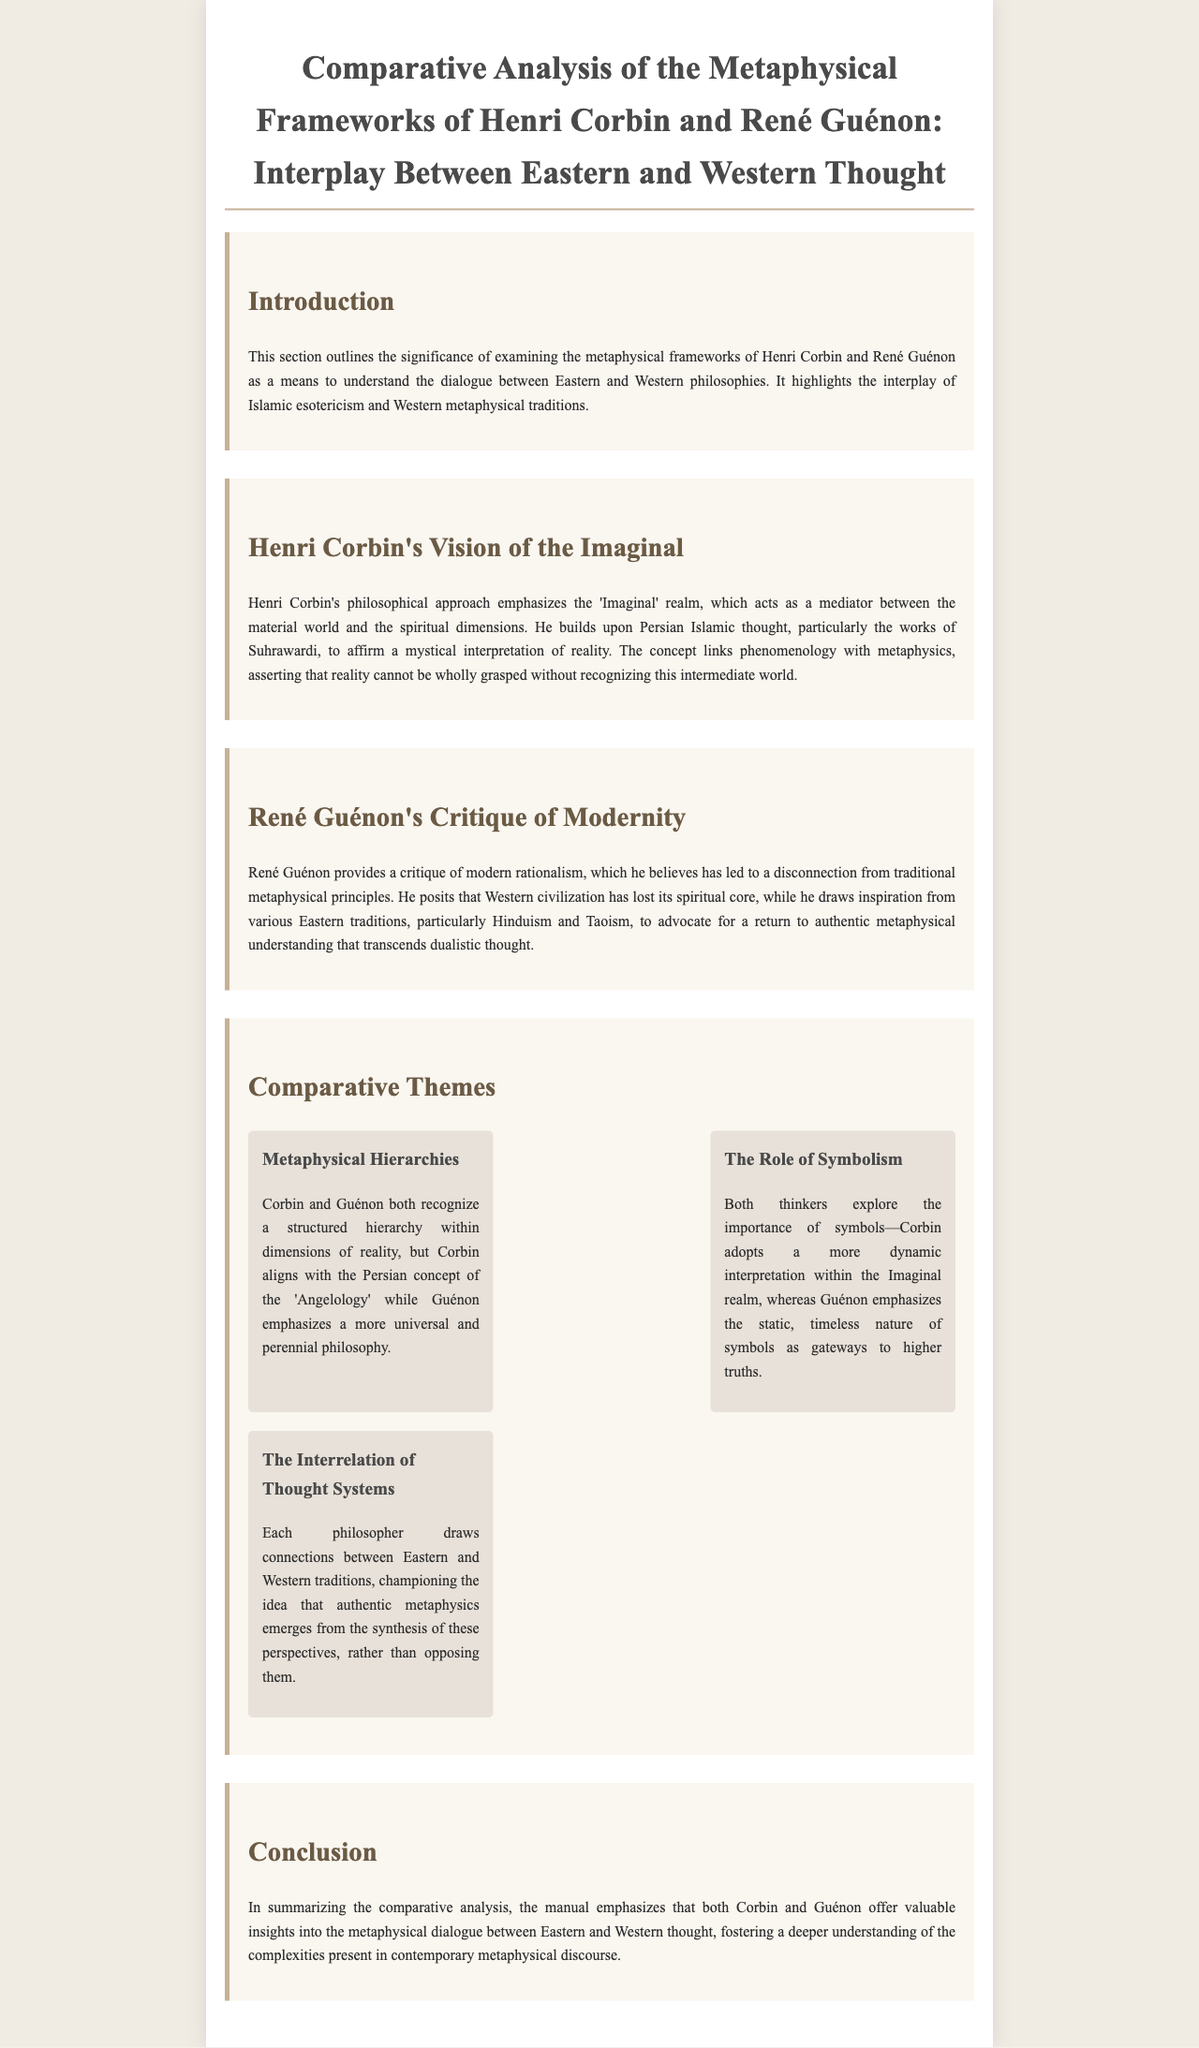What is the title of the document? The title is prominently displayed at the top of the document, which is "Comparative Analysis of the Metaphysical Frameworks of Henri Corbin and René Guénon: Interplay Between Eastern and Western Thought."
Answer: Comparative Analysis of the Metaphysical Frameworks of Henri Corbin and René Guénon: Interplay Between Eastern and Western Thought Who emphasizes the 'Imaginal' realm? The document attributes the emphasis on the 'Imaginal' realm to Henri Corbin, as noted in his philosophical approach.
Answer: Henri Corbin What does René Guénon critique? The document states that René Guénon provides a critique of modern rationalism.
Answer: Modern rationalism How many themes are discussed in the Comparative Themes section? The document lists three specific themes under the Comparative Themes section.
Answer: Three What aspect connects Corbin and Guénon’s philosophical perspectives? The document reveals that both philosophers champion the idea of a synthesis of Eastern and Western traditions.
Answer: Synthesis of Eastern and Western traditions Which tradition does Guénon draw inspiration from? The text notes that René Guénon draws inspiration from various Eastern traditions, particularly Hinduism and Taoism.
Answer: Hinduism and Taoism What concept does Corbin relate to reality? The document highlights that Corbin asserts reality cannot be fully grasped without recognizing the 'Imaginal' realm.
Answer: 'Imaginal' realm What type of symbolism does Corbin focus on? The document indicates that Corbin adopts a more dynamic interpretation of symbols within the Imaginal realm.
Answer: Dynamic interpretation 